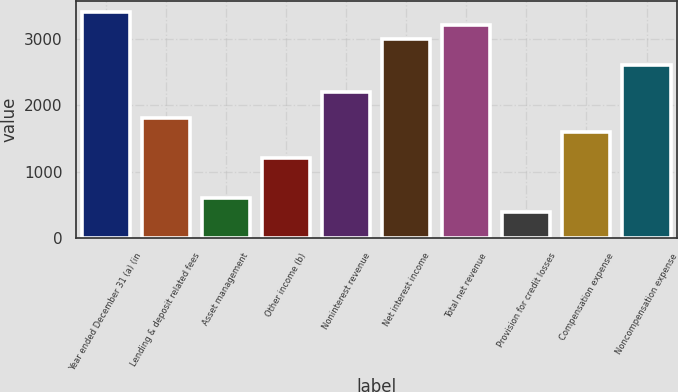<chart> <loc_0><loc_0><loc_500><loc_500><bar_chart><fcel>Year ended December 31 (a) (in<fcel>Lending & deposit related fees<fcel>Asset management<fcel>Other income (b)<fcel>Noninterest revenue<fcel>Net interest income<fcel>Total net revenue<fcel>Provision for credit losses<fcel>Compensation expense<fcel>Noncompensation expense<nl><fcel>3403.74<fcel>1802.86<fcel>602.2<fcel>1202.53<fcel>2203.08<fcel>3003.52<fcel>3203.63<fcel>402.09<fcel>1602.75<fcel>2603.3<nl></chart> 